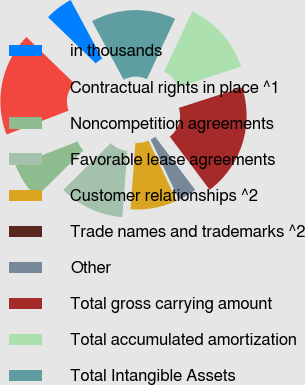<chart> <loc_0><loc_0><loc_500><loc_500><pie_chart><fcel>in thousands<fcel>Contractual rights in place ^1<fcel>Noncompetition agreements<fcel>Favorable lease agreements<fcel>Customer relationships ^2<fcel>Trade names and trademarks ^2<fcel>Other<fcel>Total gross carrying amount<fcel>Total accumulated amortization<fcel>Total Intangible Assets<nl><fcel>4.9%<fcel>18.09%<fcel>6.53%<fcel>11.43%<fcel>8.17%<fcel>0.0%<fcel>3.27%<fcel>19.72%<fcel>13.07%<fcel>14.82%<nl></chart> 